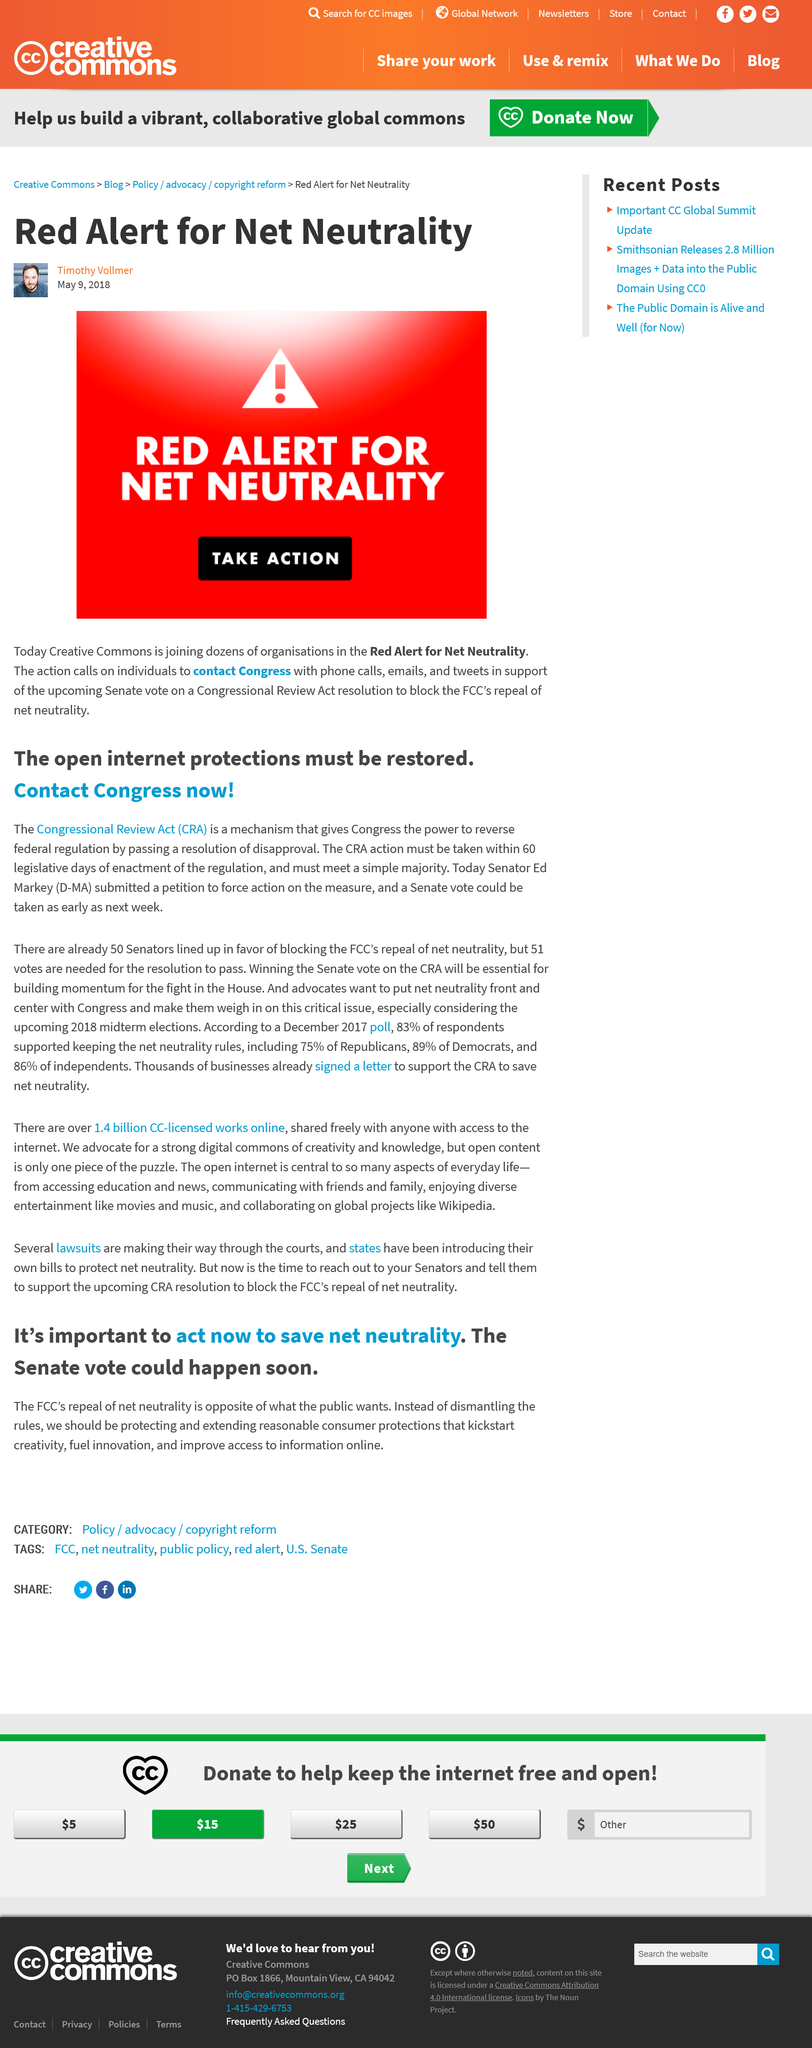Identify some key points in this picture. On May 9th 2018, the Creative Commons call for action took place. You have the ability to communicate with Congress through various methods, including phone calls, emails, and tweets. It is recommended that the public reach out to their elected representatives in Congress to support efforts to restore strong internet protections. The Congressional Review Act empowers Congress to repeal federal regulations by passing a resolution of disapproval. Creative Commons is joining the "Red Alert for Net Neutrality" action. 